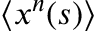Convert formula to latex. <formula><loc_0><loc_0><loc_500><loc_500>\langle x ^ { n } ( s ) \rangle</formula> 